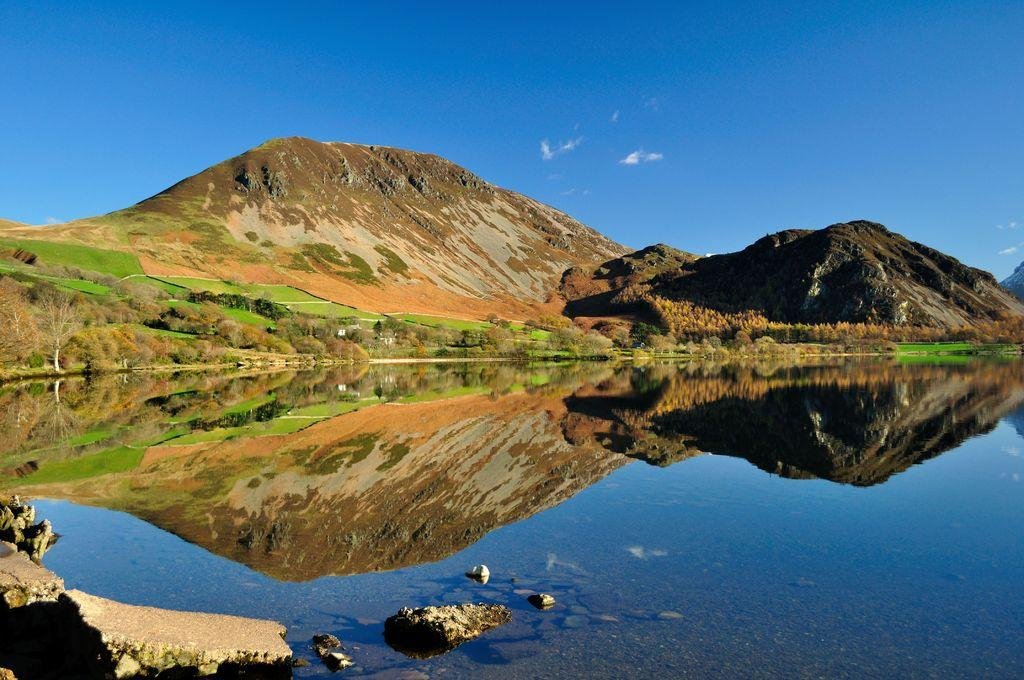What type of natural features can be seen in the image? There are trees and mountains in the image. What can be seen in the water in the image? The provided facts do not mention anything specific about the water. What is visible in the background of the image? The sky is visible in the background of the image. How many eyes can be seen on the trees in the image? Trees do not have eyes, so this question cannot be answered based on the provided facts. 